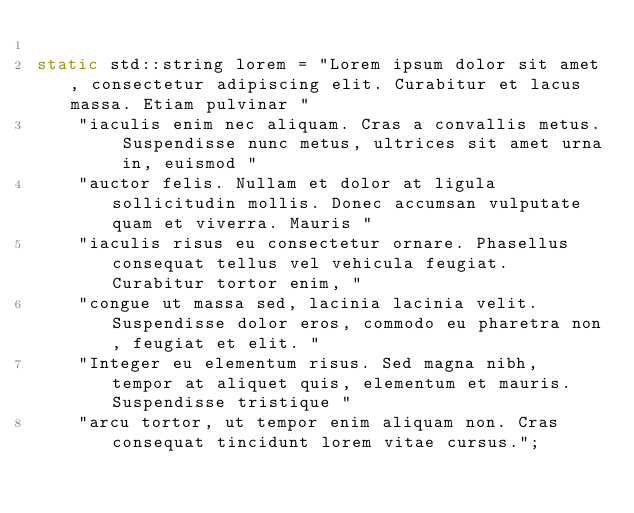Convert code to text. <code><loc_0><loc_0><loc_500><loc_500><_C++_>
static std::string lorem = "Lorem ipsum dolor sit amet, consectetur adipiscing elit. Curabitur et lacus massa. Etiam pulvinar "
    "iaculis enim nec aliquam. Cras a convallis metus. Suspendisse nunc metus, ultrices sit amet urna in, euismod "
    "auctor felis. Nullam et dolor at ligula sollicitudin mollis. Donec accumsan vulputate quam et viverra. Mauris "
    "iaculis risus eu consectetur ornare. Phasellus consequat tellus vel vehicula feugiat. Curabitur tortor enim, "
    "congue ut massa sed, lacinia lacinia velit. Suspendisse dolor eros, commodo eu pharetra non, feugiat et elit. "
    "Integer eu elementum risus. Sed magna nibh, tempor at aliquet quis, elementum et mauris. Suspendisse tristique "
    "arcu tortor, ut tempor enim aliquam non. Cras consequat tincidunt lorem vitae cursus.";
</code> 